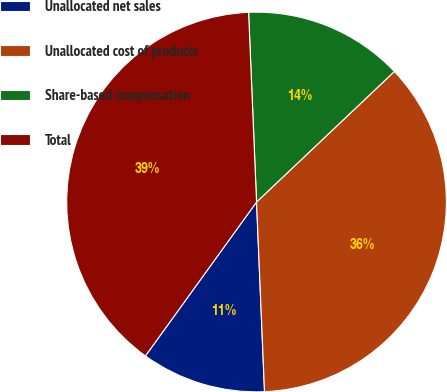<chart> <loc_0><loc_0><loc_500><loc_500><pie_chart><fcel>Unallocated net sales<fcel>Unallocated cost of products<fcel>Share-based compensation<fcel>Total<nl><fcel>10.62%<fcel>36.4%<fcel>13.6%<fcel>39.38%<nl></chart> 